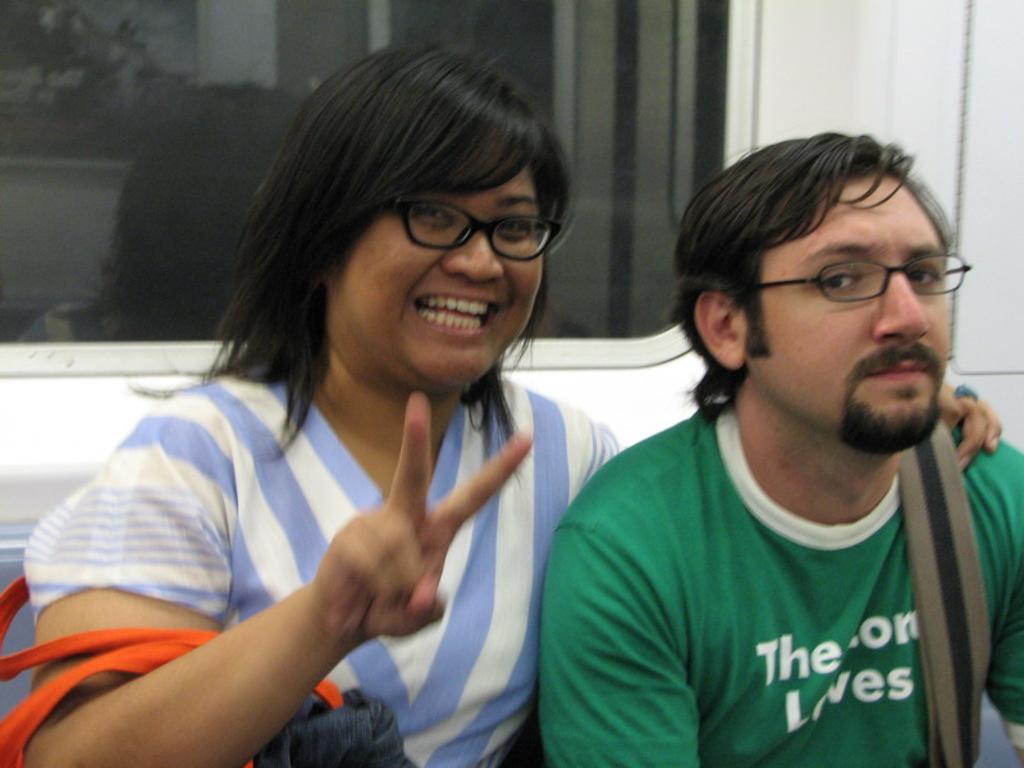Describe this image in one or two sentences. In this image there is a girl on the left side who is laughing and showing her two fingers. On the right side there is a man who is wearing the bag. In the background there is a glass window. The woman has kept her hand on the man. The woman is also wearing the handbag. 